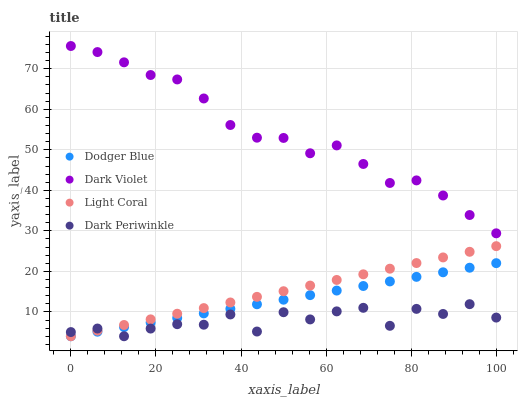Does Dark Periwinkle have the minimum area under the curve?
Answer yes or no. Yes. Does Dark Violet have the maximum area under the curve?
Answer yes or no. Yes. Does Dodger Blue have the minimum area under the curve?
Answer yes or no. No. Does Dodger Blue have the maximum area under the curve?
Answer yes or no. No. Is Dodger Blue the smoothest?
Answer yes or no. Yes. Is Dark Periwinkle the roughest?
Answer yes or no. Yes. Is Dark Periwinkle the smoothest?
Answer yes or no. No. Is Dodger Blue the roughest?
Answer yes or no. No. Does Light Coral have the lowest value?
Answer yes or no. Yes. Does Dark Violet have the lowest value?
Answer yes or no. No. Does Dark Violet have the highest value?
Answer yes or no. Yes. Does Dodger Blue have the highest value?
Answer yes or no. No. Is Dodger Blue less than Dark Violet?
Answer yes or no. Yes. Is Dark Violet greater than Light Coral?
Answer yes or no. Yes. Does Dodger Blue intersect Dark Periwinkle?
Answer yes or no. Yes. Is Dodger Blue less than Dark Periwinkle?
Answer yes or no. No. Is Dodger Blue greater than Dark Periwinkle?
Answer yes or no. No. Does Dodger Blue intersect Dark Violet?
Answer yes or no. No. 